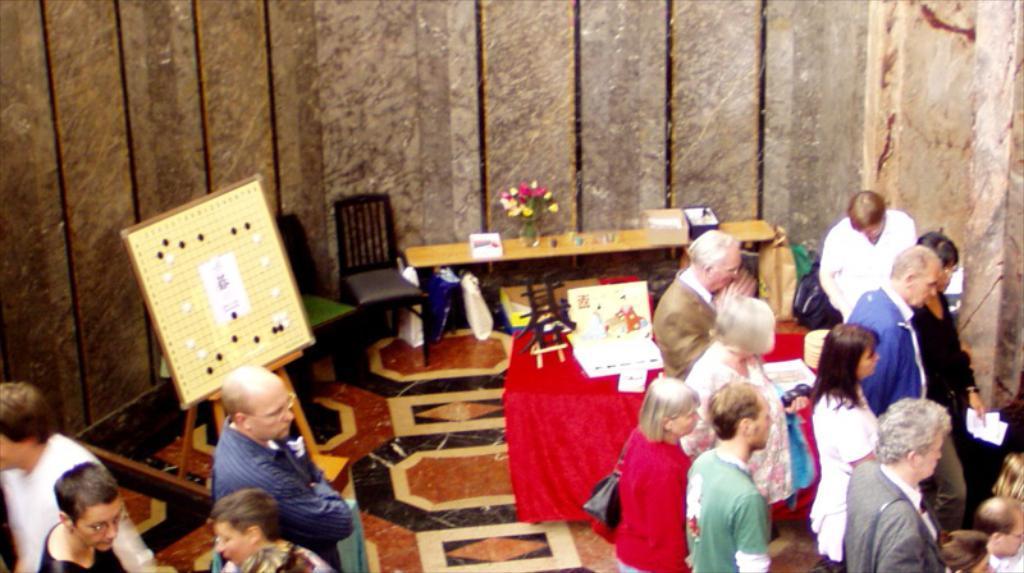How would you summarize this image in a sentence or two? In this image there are group of people standing, and there is a flower vase and some objects on the tables, chairs , there is a board with a stand. 